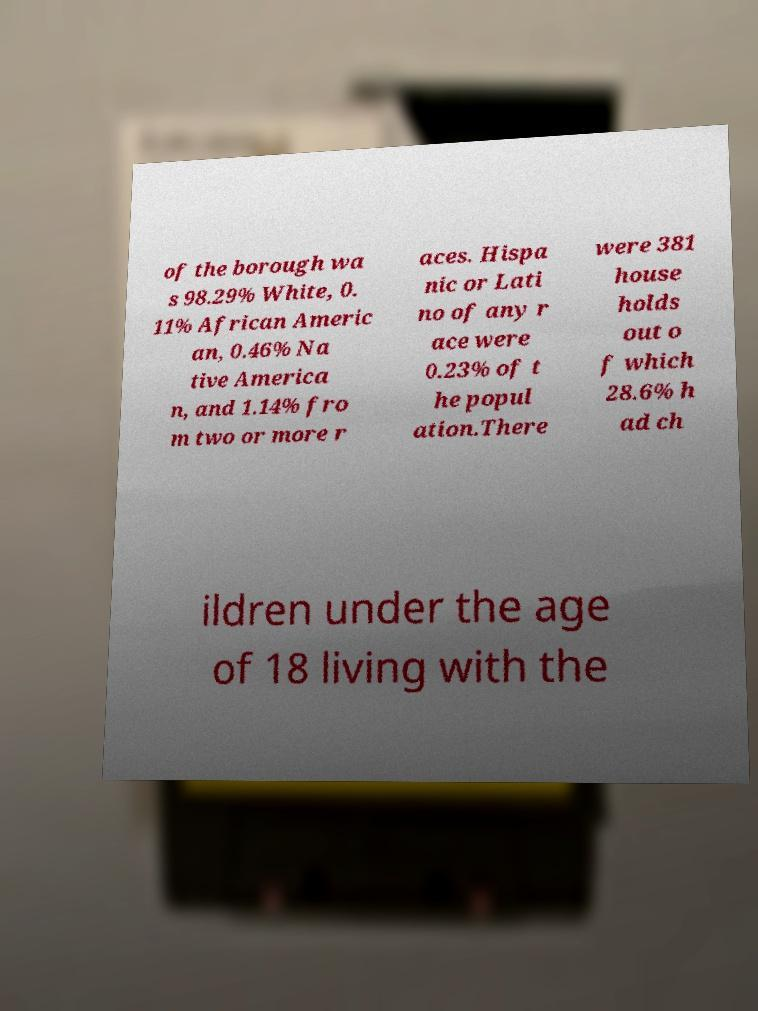Can you accurately transcribe the text from the provided image for me? of the borough wa s 98.29% White, 0. 11% African Americ an, 0.46% Na tive America n, and 1.14% fro m two or more r aces. Hispa nic or Lati no of any r ace were 0.23% of t he popul ation.There were 381 house holds out o f which 28.6% h ad ch ildren under the age of 18 living with the 